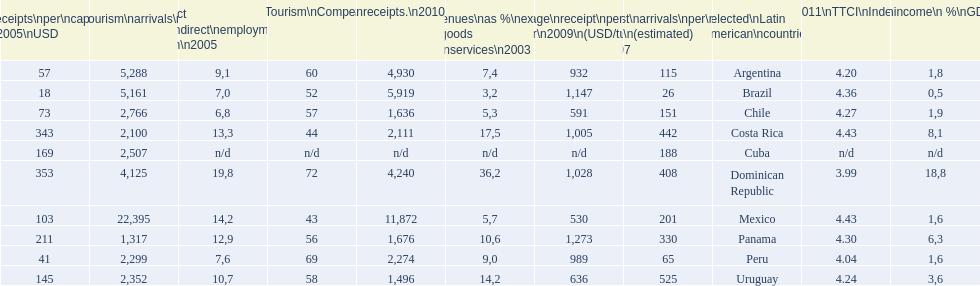What country makes the most tourist income? Dominican Republic. 